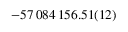<formula> <loc_0><loc_0><loc_500><loc_500>- 5 7 \, 0 8 4 \, 1 5 6 . 5 1 ( 1 2 )</formula> 